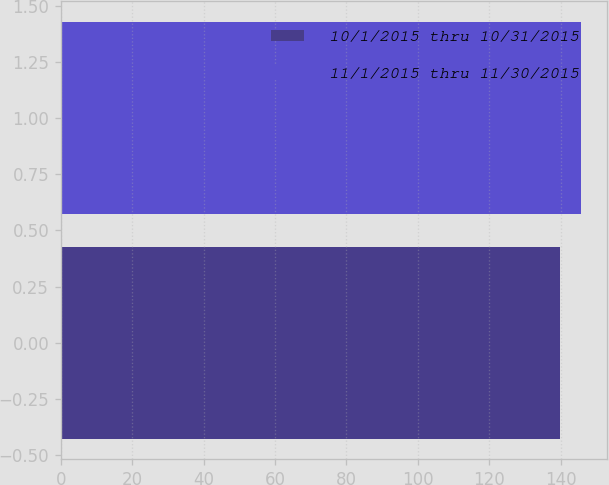Convert chart. <chart><loc_0><loc_0><loc_500><loc_500><bar_chart><fcel>10/1/2015 thru 10/31/2015<fcel>11/1/2015 thru 11/30/2015<nl><fcel>139.77<fcel>145.83<nl></chart> 